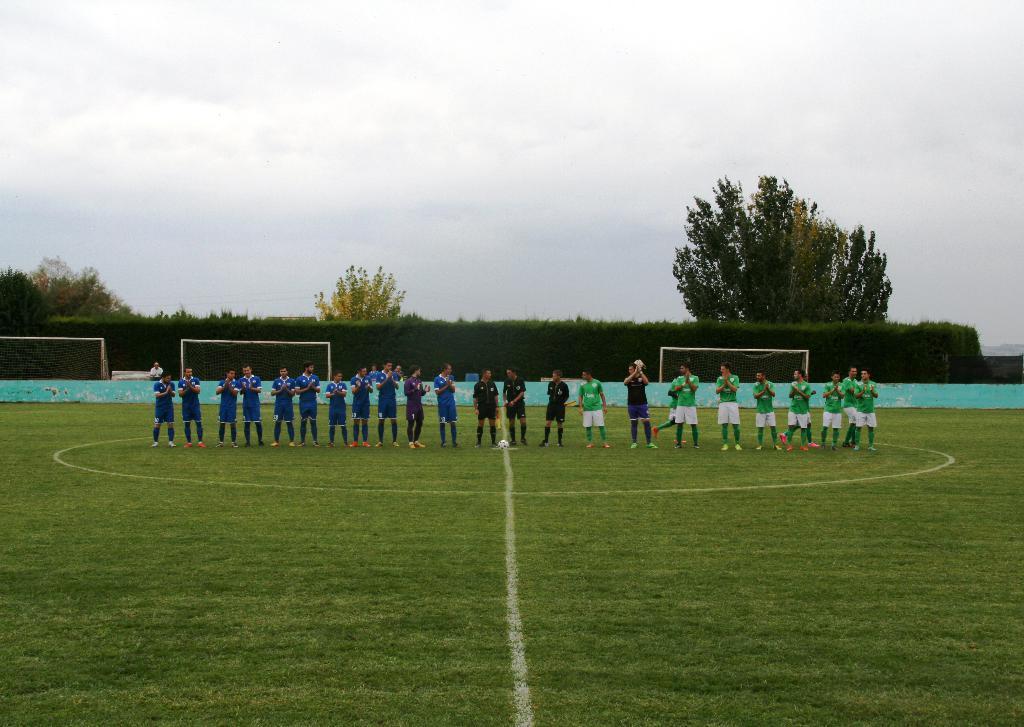Can you describe this image briefly? In this picture we can see some people are standing on the ground, at the bottom there is grass, we can see a football in the middle, in the background we can see trees, shrubs and nets, there is the sky at the top of the picture. 